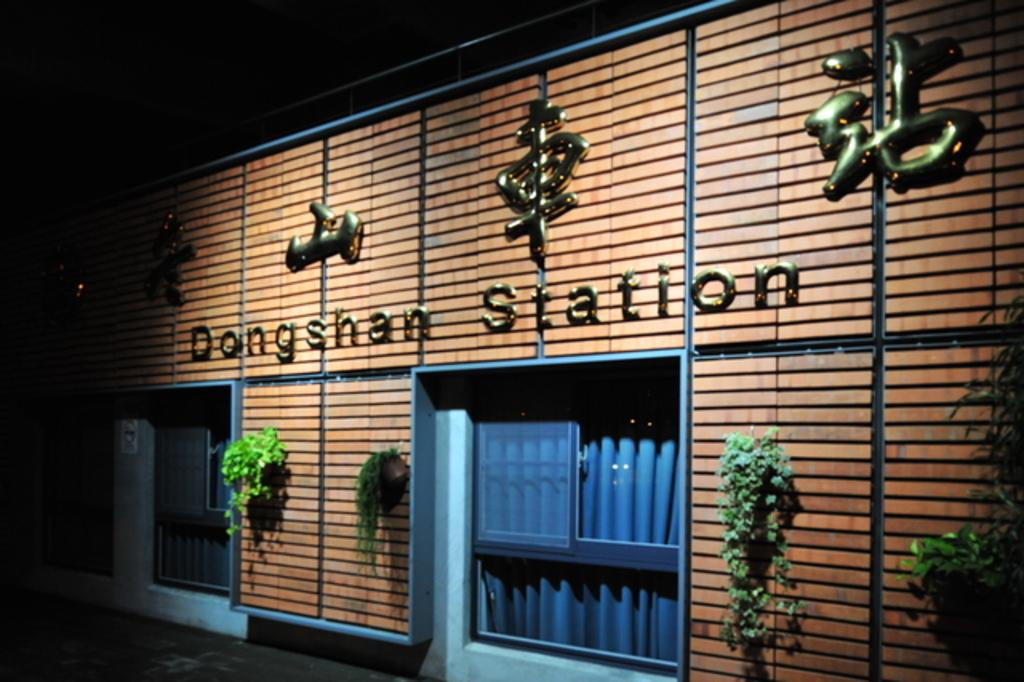What is present on the wall in the image? There are plants on the wall in the image. Can you describe the plants on the wall? The provided facts do not give specific details about the plants, so we cannot describe them further. Who is the representative of the error in the order in the image? There is no mention of a representative, error, or order in the image, so this question cannot be answered. 